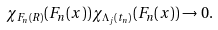<formula> <loc_0><loc_0><loc_500><loc_500>\chi _ { F _ { n } ( R ) } ( F _ { n } ( x ) ) \chi _ { \Lambda _ { j } ( t _ { n } ) } ( F _ { n } ( x ) ) \to 0 .</formula> 